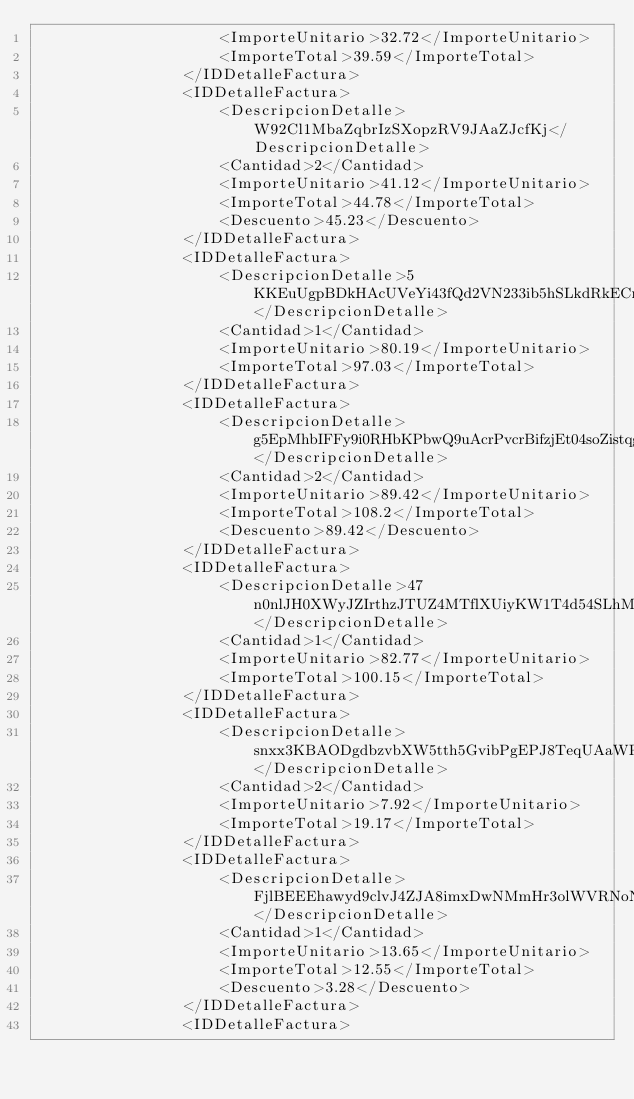<code> <loc_0><loc_0><loc_500><loc_500><_XML_>                    <ImporteUnitario>32.72</ImporteUnitario>
                    <ImporteTotal>39.59</ImporteTotal>
                </IDDetalleFactura>
                <IDDetalleFactura>
                    <DescripcionDetalle>W92Cl1MbaZqbrIzSXopzRV9JAaZJcfKj</DescripcionDetalle>
                    <Cantidad>2</Cantidad>
                    <ImporteUnitario>41.12</ImporteUnitario>
                    <ImporteTotal>44.78</ImporteTotal>
                    <Descuento>45.23</Descuento>
                </IDDetalleFactura>
                <IDDetalleFactura>
                    <DescripcionDetalle>5KKEuUgpBDkHAcUVeYi43fQd2VN233ib5hSLkdRkECmKLGxdYMvPOlV6L4pDjGVHmgQWpCfrjvchPH9rSvwqLVAlGRvlMJyXwNdawgYFgzCE2XuO3eRXcZdrc12XFNIRWIBvUpqzE7IgsPOoGZ2WmW3zWTW0ym7QvsoamlUICBtCiUCblksxjih60sKWoqVgBJ6VE8wfN8xpYlZAhlPncj6oXyqHbtcRoT74</DescripcionDetalle>
                    <Cantidad>1</Cantidad>
                    <ImporteUnitario>80.19</ImporteUnitario>
                    <ImporteTotal>97.03</ImporteTotal>
                </IDDetalleFactura>
                <IDDetalleFactura>
                    <DescripcionDetalle>g5EpMhbIFFy9i0RHbKPbwQ9uAcrPvcrBifzjEt04soZistqgZAyhX1DuvOXYSApQ0ZXqXBFpkGYKfxukN8NqQkmB67YDTBMHp2H3rCAquVnJyUPZ34RbqRJURxobFLcUF73A9MVaDBNW7p4wmQoXRBMW3RmHS8aRFehZfQLVNCfv2QXCmC7OM0IhqXKYdPRNiQZ7lmLWf92PT5m37H9w5vjJ5C333Vnr4ucMP0StM</DescripcionDetalle>
                    <Cantidad>2</Cantidad>
                    <ImporteUnitario>89.42</ImporteUnitario>
                    <ImporteTotal>108.2</ImporteTotal>
                    <Descuento>89.42</Descuento>
                </IDDetalleFactura>
                <IDDetalleFactura>
                    <DescripcionDetalle>47n0nlJH0XWyJZIrthzJTUZ4MTflXUiyKW1T4d54SLhM7XLzeh61BI7kwE7NFGFzUJpwp2Tpid8hIpS3x0FcH36nq3dXWpZb9XpRblpFcpT0a7hWPIMWF9AqUMK2ug6QYaJVUaj5iMjkFzTP6C0T6LVgOFmS6evxE9fMH3lADQ9VGuBc4dlXkeHMVRtxUeN</DescripcionDetalle>
                    <Cantidad>1</Cantidad>
                    <ImporteUnitario>82.77</ImporteUnitario>
                    <ImporteTotal>100.15</ImporteTotal>
                </IDDetalleFactura>
                <IDDetalleFactura>
                    <DescripcionDetalle>snxx3KBAODgdbzvbXW5tth5GvibPgEPJ8TeqUAaWPgGKynT2xTGYddeczCzq3dHsyYSvFOF160rl0p9ieqRsWRbIOLjADDalzMeQDxlIZUi9shKBTzrNl5km0dSVBnUnKpCkUYNdapda6GwuVucISmRtFNMZ5zatIgWH96T3FoTca</DescripcionDetalle>
                    <Cantidad>2</Cantidad>
                    <ImporteUnitario>7.92</ImporteUnitario>
                    <ImporteTotal>19.17</ImporteTotal>
                </IDDetalleFactura>
                <IDDetalleFactura>
                    <DescripcionDetalle>FjlBEEEhawyd9clvJ4ZJA8imxDwNMmHr3olWVRNoNGwL2Wlogulk1EkgE1vOl7hwvnvHiRlhslRGgByvReDnczEk1pEEJaLHeQnCqPmg</DescripcionDetalle>
                    <Cantidad>1</Cantidad>
                    <ImporteUnitario>13.65</ImporteUnitario>
                    <ImporteTotal>12.55</ImporteTotal>
                    <Descuento>3.28</Descuento>
                </IDDetalleFactura>
                <IDDetalleFactura></code> 